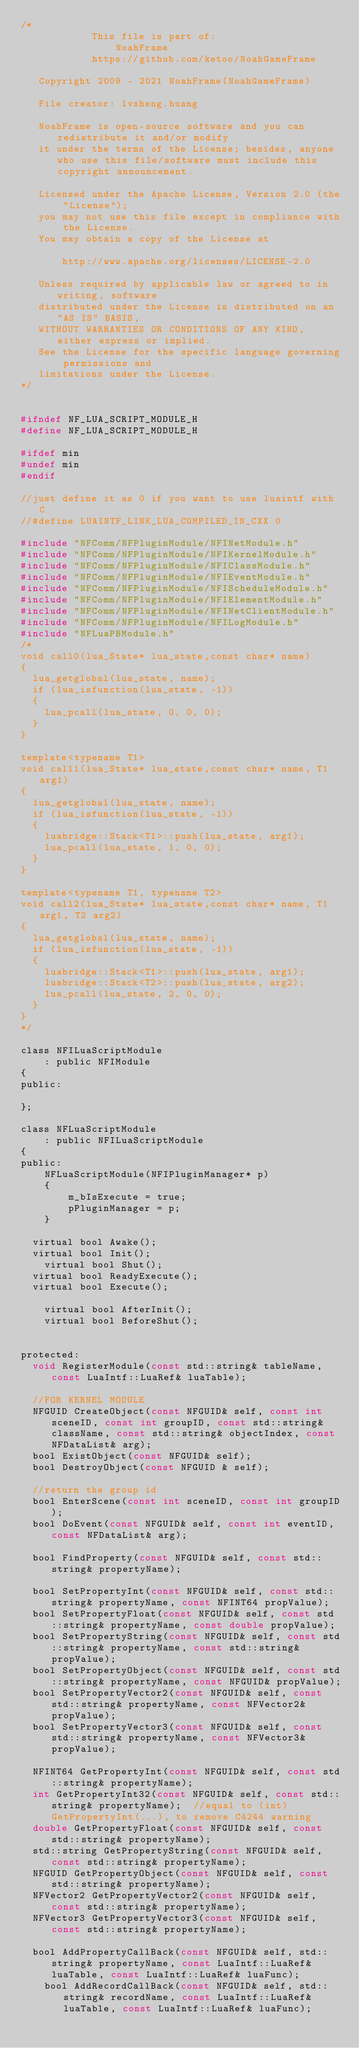Convert code to text. <code><loc_0><loc_0><loc_500><loc_500><_C_>/*
            This file is part of: 
                NoahFrame
            https://github.com/ketoo/NoahGameFrame

   Copyright 2009 - 2021 NoahFrame(NoahGameFrame)

   File creator: lvsheng.huang
   
   NoahFrame is open-source software and you can redistribute it and/or modify
   it under the terms of the License; besides, anyone who use this file/software must include this copyright announcement.

   Licensed under the Apache License, Version 2.0 (the "License");
   you may not use this file except in compliance with the License.
   You may obtain a copy of the License at

       http://www.apache.org/licenses/LICENSE-2.0

   Unless required by applicable law or agreed to in writing, software
   distributed under the License is distributed on an "AS IS" BASIS,
   WITHOUT WARRANTIES OR CONDITIONS OF ANY KIND, either express or implied.
   See the License for the specific language governing permissions and
   limitations under the License.
*/


#ifndef NF_LUA_SCRIPT_MODULE_H
#define NF_LUA_SCRIPT_MODULE_H

#ifdef min
#undef min
#endif

//just define it as 0 if you want to use luaintf with C
//#define LUAINTF_LINK_LUA_COMPILED_IN_CXX 0

#include "NFComm/NFPluginModule/NFINetModule.h"
#include "NFComm/NFPluginModule/NFIKernelModule.h"
#include "NFComm/NFPluginModule/NFIClassModule.h"
#include "NFComm/NFPluginModule/NFIEventModule.h"
#include "NFComm/NFPluginModule/NFIScheduleModule.h"
#include "NFComm/NFPluginModule/NFIElementModule.h"
#include "NFComm/NFPluginModule/NFINetClientModule.h"
#include "NFComm/NFPluginModule/NFILogModule.h"
#include "NFLuaPBModule.h"
/*
void call0(lua_State* lua_state,const char* name)
{
	lua_getglobal(lua_state, name);
	if (lua_isfunction(lua_state, -1))
	{
		lua_pcall(lua_state, 0, 0, 0);
	}
}

template<typename T1>
void call1(lua_State* lua_state,const char* name, T1 arg1)
{
	lua_getglobal(lua_state, name);
	if (lua_isfunction(lua_state, -1))
	{
		luabridge::Stack<T1>::push(lua_state, arg1);
		lua_pcall(lua_state, 1, 0, 0);
	}
}

template<typename T1, typename T2>
void call2(lua_State* lua_state,const char* name, T1 arg1, T2 arg2)
{
	lua_getglobal(lua_state, name);
	if (lua_isfunction(lua_state, -1))
	{
		luabridge::Stack<T1>::push(lua_state, arg1);
		luabridge::Stack<T2>::push(lua_state, arg2);
		lua_pcall(lua_state, 2, 0, 0);
	}
}
*/

class NFILuaScriptModule
		: public NFIModule
{
public:

};

class NFLuaScriptModule
    : public NFILuaScriptModule
{
public:
    NFLuaScriptModule(NFIPluginManager* p)
    {
        m_bIsExecute = true;
        pPluginManager = p;
    }

	virtual bool Awake();
	virtual bool Init();
    virtual bool Shut();
	virtual bool ReadyExecute();
	virtual bool Execute();

    virtual bool AfterInit();
    virtual bool BeforeShut();


protected:
	void RegisterModule(const std::string& tableName, const LuaIntf::LuaRef& luaTable);

	//FOR KERNEL MODULE
	NFGUID CreateObject(const NFGUID& self, const int sceneID, const int groupID, const std::string& className, const std::string& objectIndex, const NFDataList& arg);
	bool ExistObject(const NFGUID& self);
	bool DestroyObject(const NFGUID & self);

	//return the group id
	bool EnterScene(const int sceneID, const int groupID);
	bool DoEvent(const NFGUID& self, const int eventID, const NFDataList& arg);

	bool FindProperty(const NFGUID& self, const std::string& propertyName);

	bool SetPropertyInt(const NFGUID& self, const std::string& propertyName, const NFINT64 propValue);
	bool SetPropertyFloat(const NFGUID& self, const std::string& propertyName, const double propValue);
	bool SetPropertyString(const NFGUID& self, const std::string& propertyName, const std::string& propValue);
	bool SetPropertyObject(const NFGUID& self, const std::string& propertyName, const NFGUID& propValue);
	bool SetPropertyVector2(const NFGUID& self, const std::string& propertyName, const NFVector2& propValue);
	bool SetPropertyVector3(const NFGUID& self, const std::string& propertyName, const NFVector3& propValue);

	NFINT64 GetPropertyInt(const NFGUID& self, const std::string& propertyName);
	int GetPropertyInt32(const NFGUID& self, const std::string& propertyName);	//equal to (int)GetPropertyInt(...), to remove C4244 warning
	double GetPropertyFloat(const NFGUID& self, const std::string& propertyName);
	std::string GetPropertyString(const NFGUID& self, const std::string& propertyName);
	NFGUID GetPropertyObject(const NFGUID& self, const std::string& propertyName);
	NFVector2 GetPropertyVector2(const NFGUID& self, const std::string& propertyName);
	NFVector3 GetPropertyVector3(const NFGUID& self, const std::string& propertyName);

	bool AddPropertyCallBack(const NFGUID& self, std::string& propertyName, const LuaIntf::LuaRef& luaTable, const LuaIntf::LuaRef& luaFunc);
    bool AddRecordCallBack(const NFGUID& self, std::string& recordName, const LuaIntf::LuaRef& luaTable, const LuaIntf::LuaRef& luaFunc);</code> 